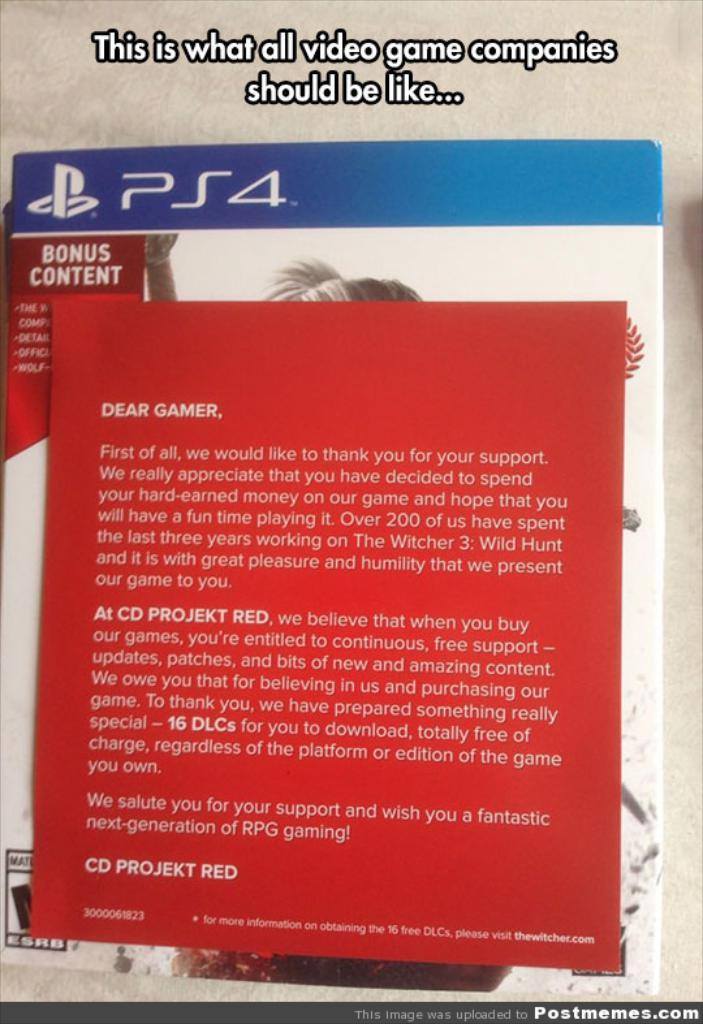Provide a one-sentence caption for the provided image. A book about PS4 has a note on top of it that starts with "Dear Gamer". 